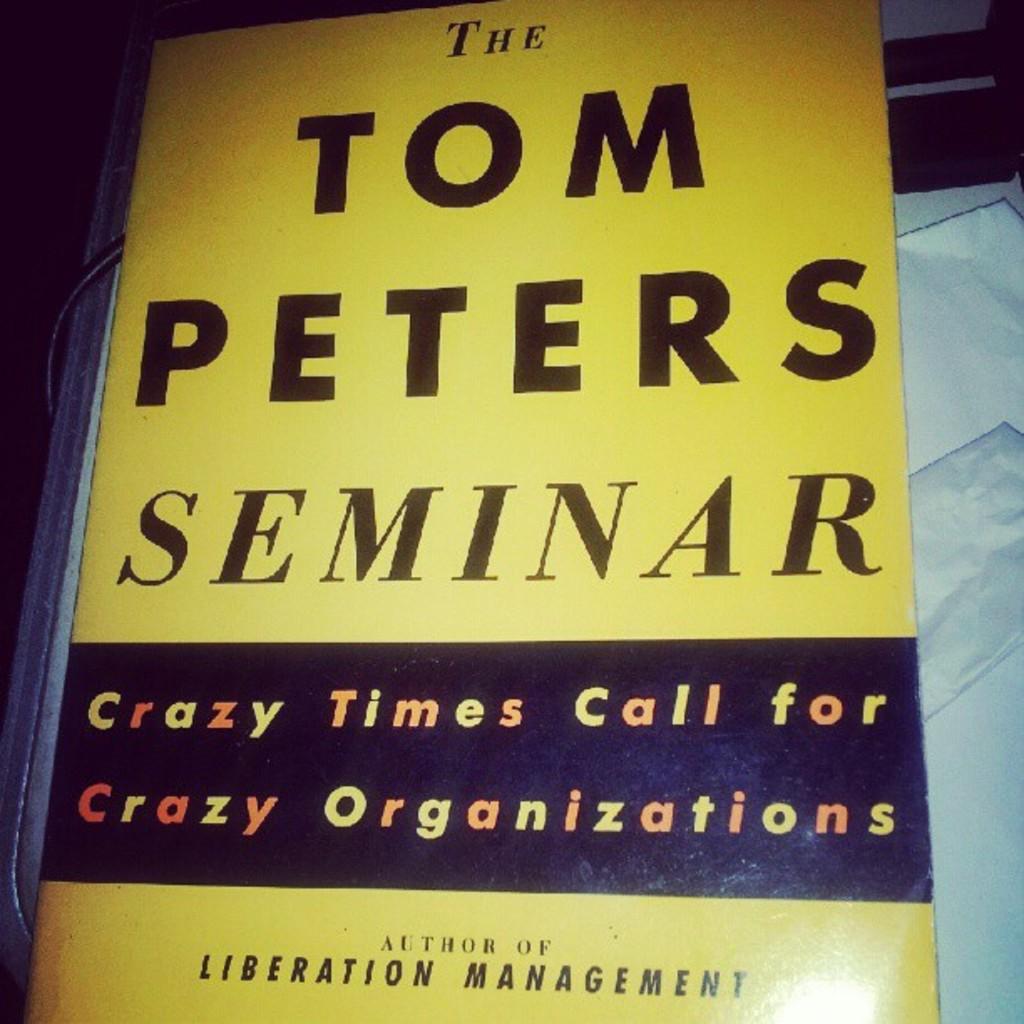Who is the author of liberation management?
Keep it short and to the point. Tom peters. What do crazy times call for?
Ensure brevity in your answer.  Crazy organizations. 